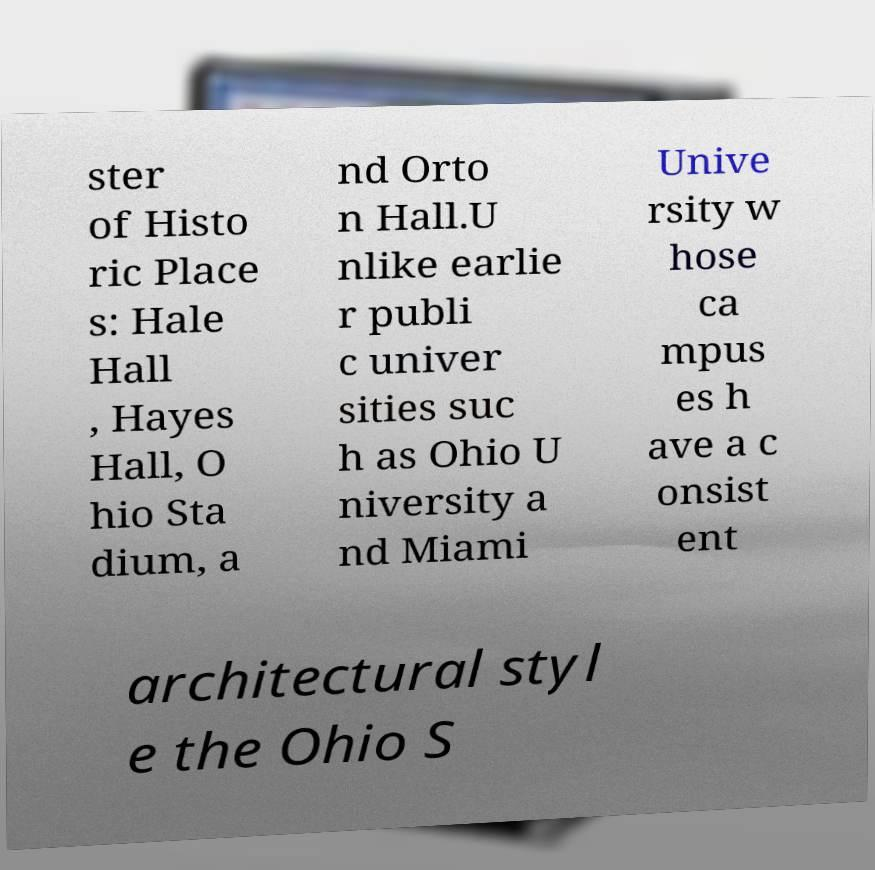Could you assist in decoding the text presented in this image and type it out clearly? ster of Histo ric Place s: Hale Hall , Hayes Hall, O hio Sta dium, a nd Orto n Hall.U nlike earlie r publi c univer sities suc h as Ohio U niversity a nd Miami Unive rsity w hose ca mpus es h ave a c onsist ent architectural styl e the Ohio S 